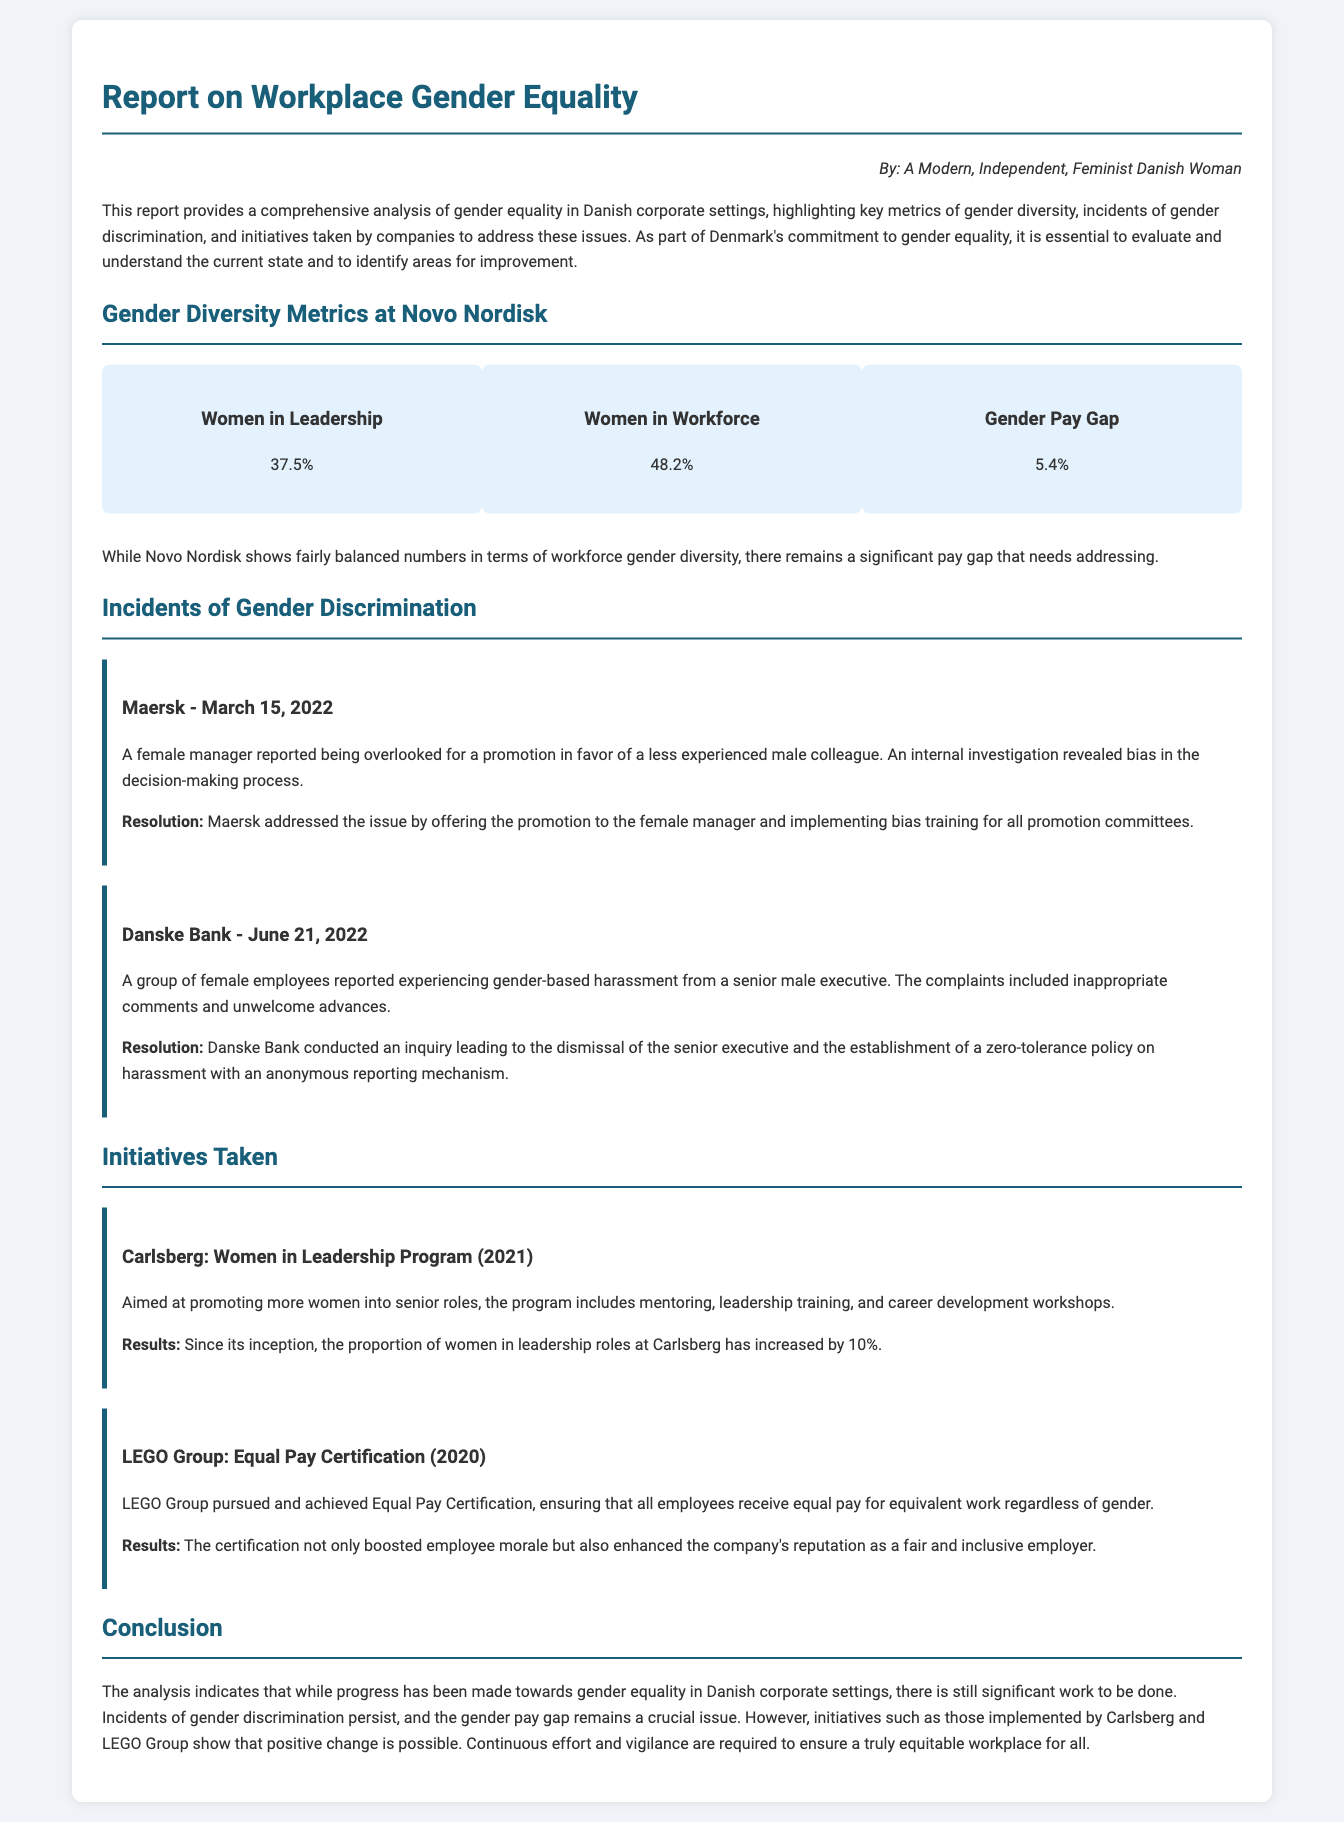What is the percentage of women in leadership at Novo Nordisk? The document states that 37.5% of women hold leadership positions at Novo Nordisk.
Answer: 37.5% What was the resolution for the incident at Maersk? The resolution involved offering the promotion to the female manager and implementing bias training for all promotion committees.
Answer: Promotion and bias training When did the incident at Danske Bank occur? The document indicates that the incident at Danske Bank took place on June 21, 2022.
Answer: June 21, 2022 What initiative did Carlsberg implement in 2021? The initiative implemented by Carlsberg in 2021 was the Women in Leadership Program.
Answer: Women in Leadership Program What is the gender pay gap reported for Novo Nordisk? The gender pay gap reported for Novo Nordisk is 5.4%.
Answer: 5.4% Which company achieved Equal Pay Certification in 2020? The document mentions that LEGO Group achieved the Equal Pay Certification in 2020.
Answer: LEGO Group What was the increase in the proportion of women in leadership roles at Carlsberg since the program started? The proportion of women in leadership roles at Carlsberg increased by 10%.
Answer: 10% What type of incident was reported at Danske Bank? The incident reported at Danske Bank was about gender-based harassment from a senior male executive.
Answer: Gender-based harassment What does the report suggest is required for achieving equity in the workplace? The report suggests that continuous effort and vigilance are required to ensure equity in the workplace.
Answer: Continuous effort and vigilance 